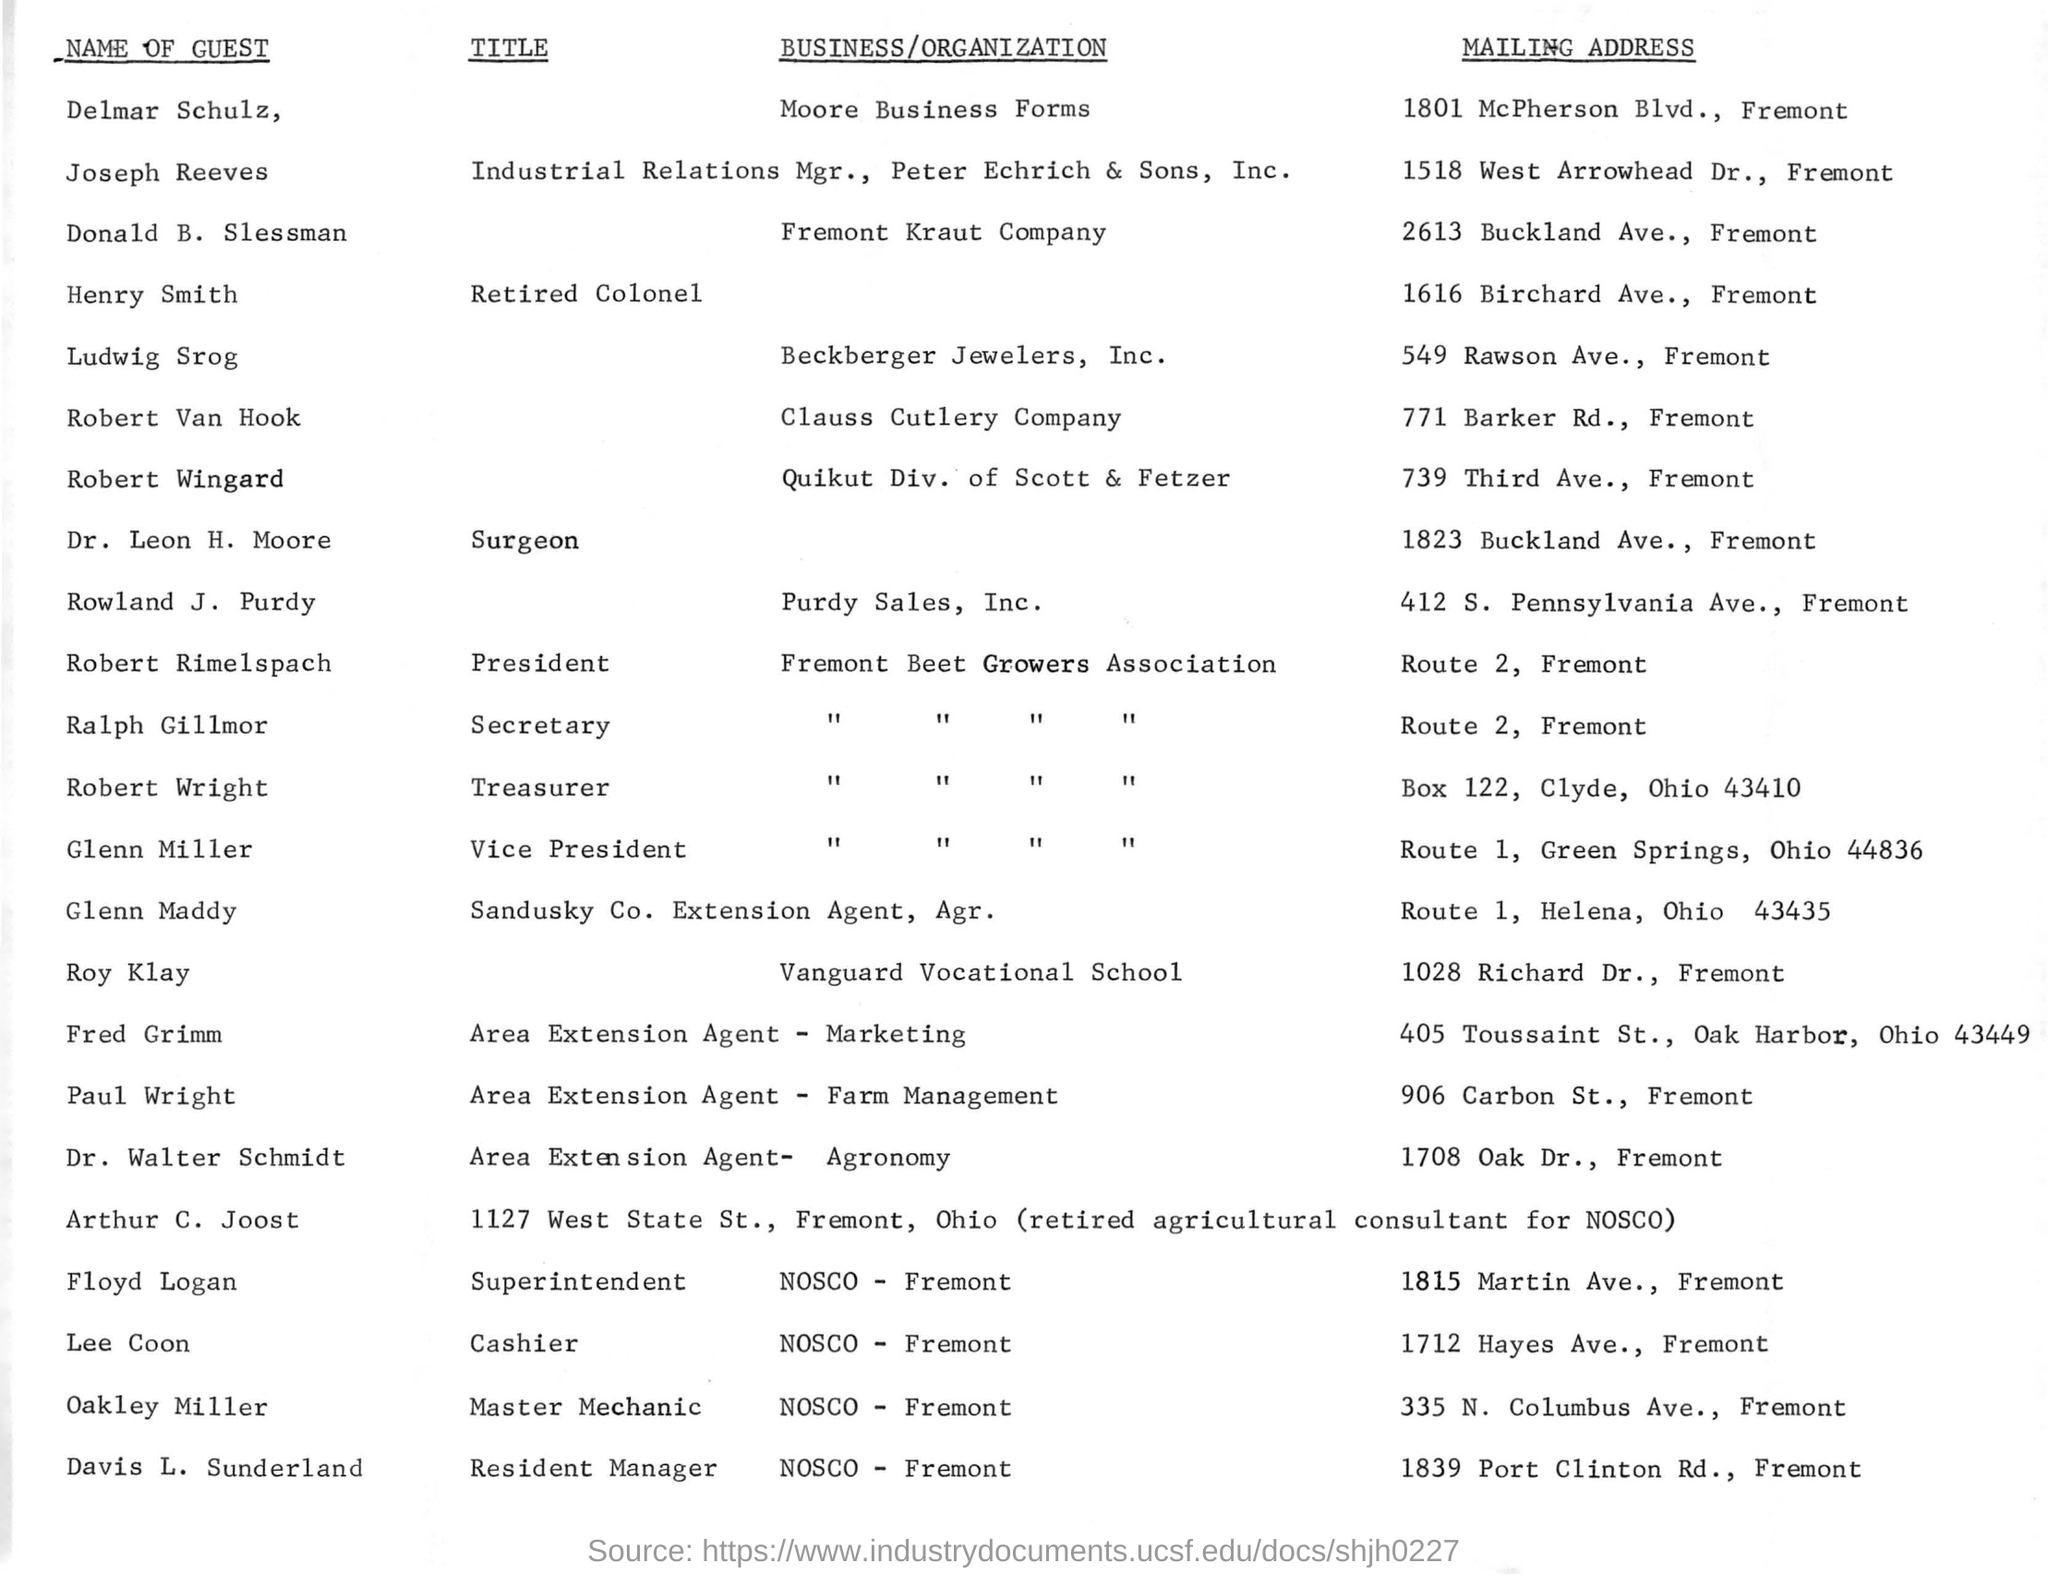Give some essential details in this illustration. The mailing address of Delmar Schulz is located at 1801 McPherson Boulevard in Fremont. The title of Dr. Leon H. Moore, a surgeon, is [object of comparison]. Lee Coon is the only cashier in the list. The mailing address of Glenn Maddy is Route 1, Helena, Ohio 43435. 